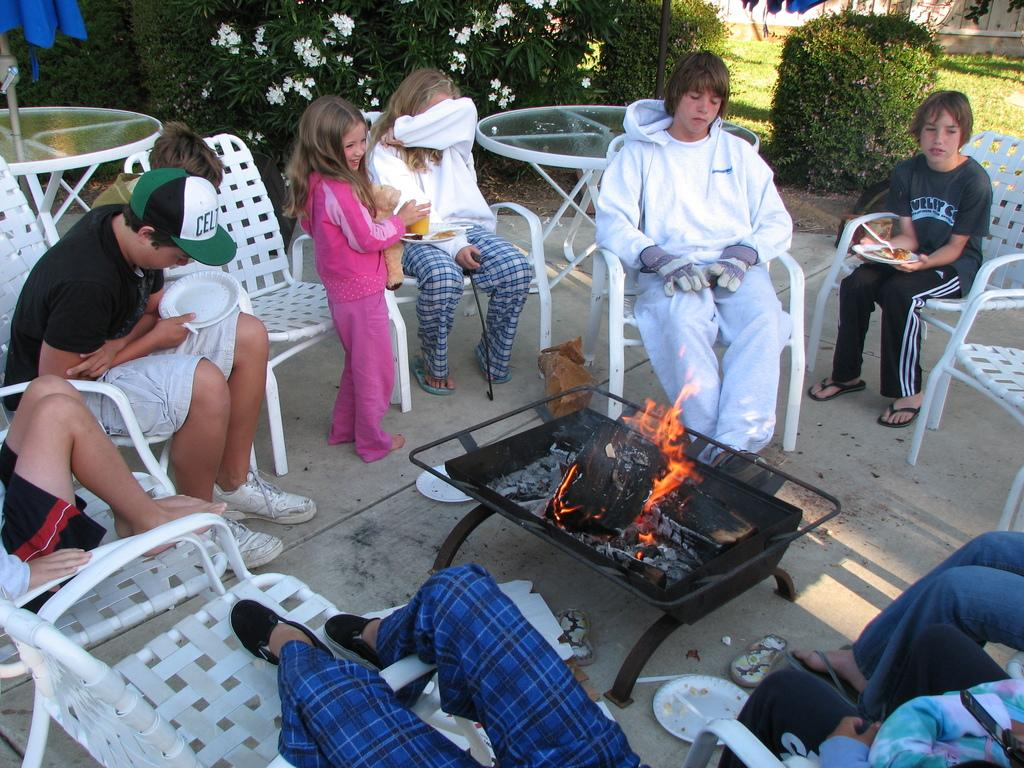<image>
Present a compact description of the photo's key features. A family is gathered around the firepit and one of the boys has a green celtics cap. 